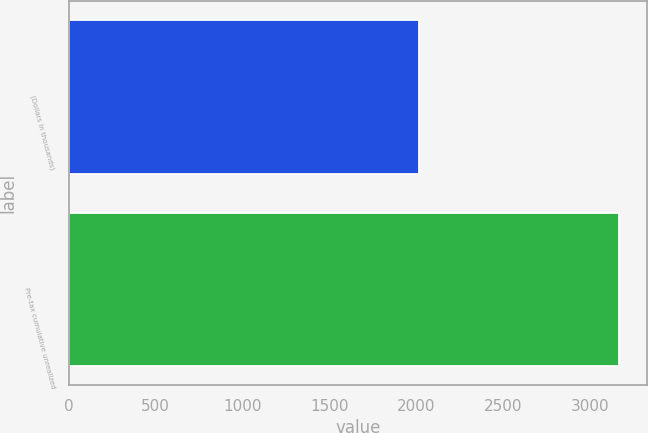Convert chart. <chart><loc_0><loc_0><loc_500><loc_500><bar_chart><fcel>(Dollars in thousands)<fcel>Pre-tax cumulative unrealized<nl><fcel>2013<fcel>3169<nl></chart> 